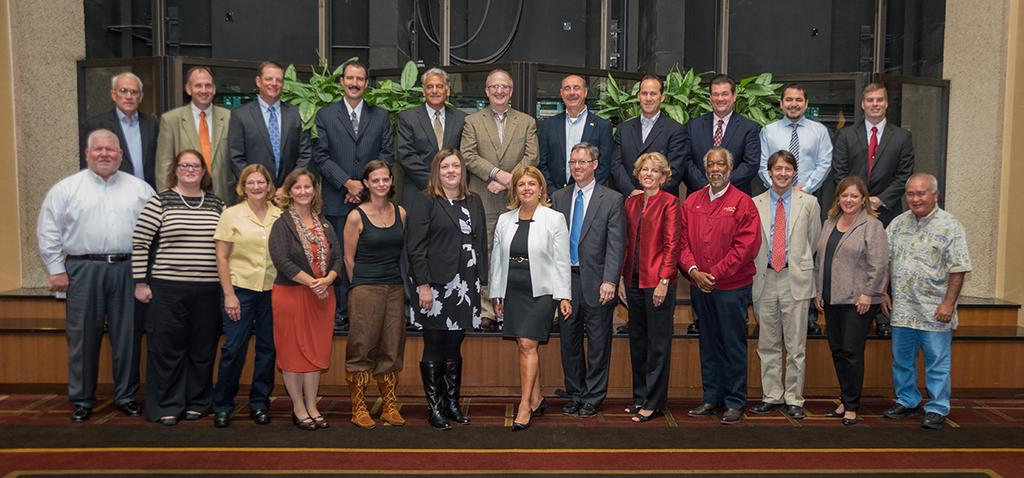How many people are present in the image? There are many persons standing in the image. Where are the persons standing? The persons are standing on the floor. What can be seen in the background of the image? There are plants and a building in the background of the image. Who is the friend standing next to the person in the image? There is no specific friend mentioned or identifiable in the image. 